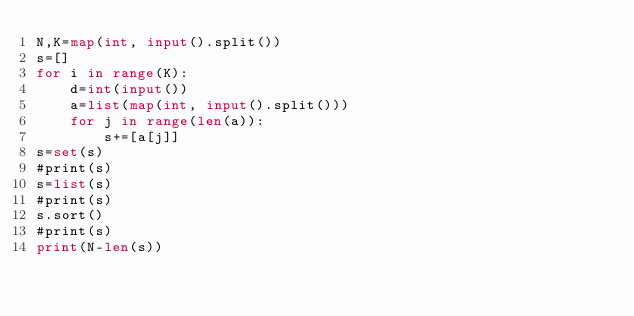<code> <loc_0><loc_0><loc_500><loc_500><_Python_>N,K=map(int, input().split())
s=[]
for i in range(K):
    d=int(input())
    a=list(map(int, input().split()))
    for j in range(len(a)):
        s+=[a[j]]
s=set(s)
#print(s)
s=list(s)
#print(s)
s.sort()
#print(s)
print(N-len(s))</code> 